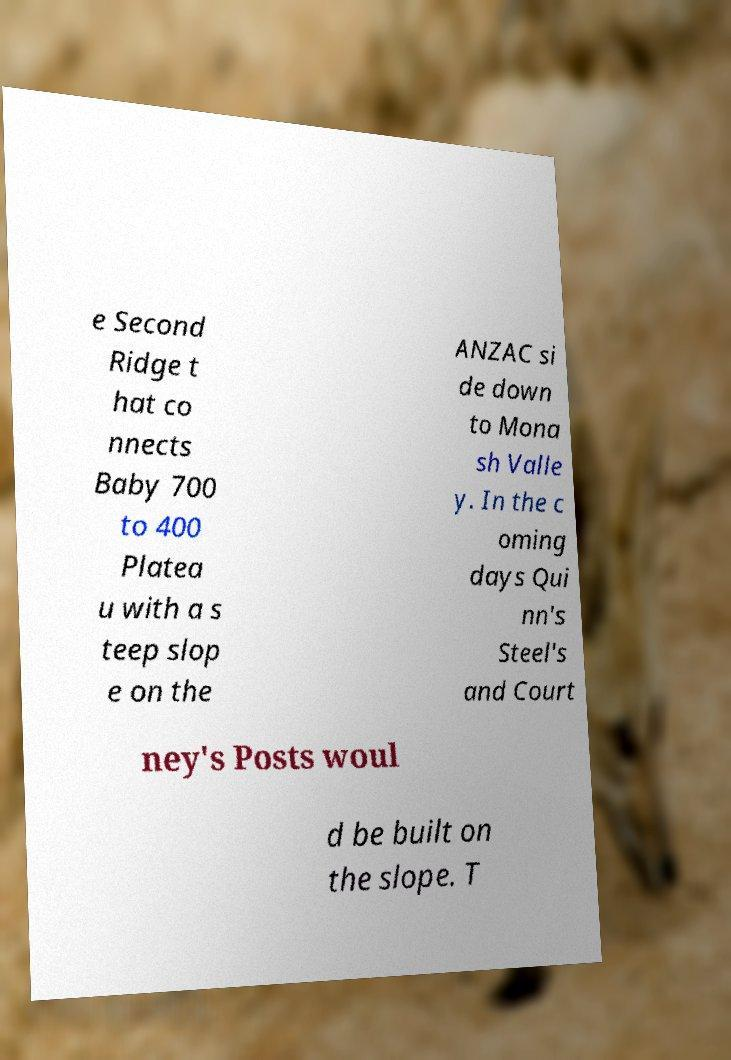Can you read and provide the text displayed in the image?This photo seems to have some interesting text. Can you extract and type it out for me? e Second Ridge t hat co nnects Baby 700 to 400 Platea u with a s teep slop e on the ANZAC si de down to Mona sh Valle y. In the c oming days Qui nn's Steel's and Court ney's Posts woul d be built on the slope. T 